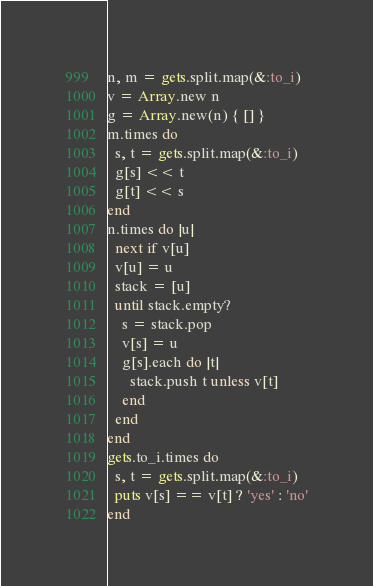Convert code to text. <code><loc_0><loc_0><loc_500><loc_500><_Ruby_>n, m = gets.split.map(&:to_i)
v = Array.new n
g = Array.new(n) { [] }
m.times do
  s, t = gets.split.map(&:to_i)
  g[s] << t
  g[t] << s
end
n.times do |u|
  next if v[u]
  v[u] = u
  stack = [u]
  until stack.empty?
    s = stack.pop
    v[s] = u
    g[s].each do |t|
      stack.push t unless v[t]
    end
  end
end
gets.to_i.times do
  s, t = gets.split.map(&:to_i)
  puts v[s] == v[t] ? 'yes' : 'no'
end</code> 